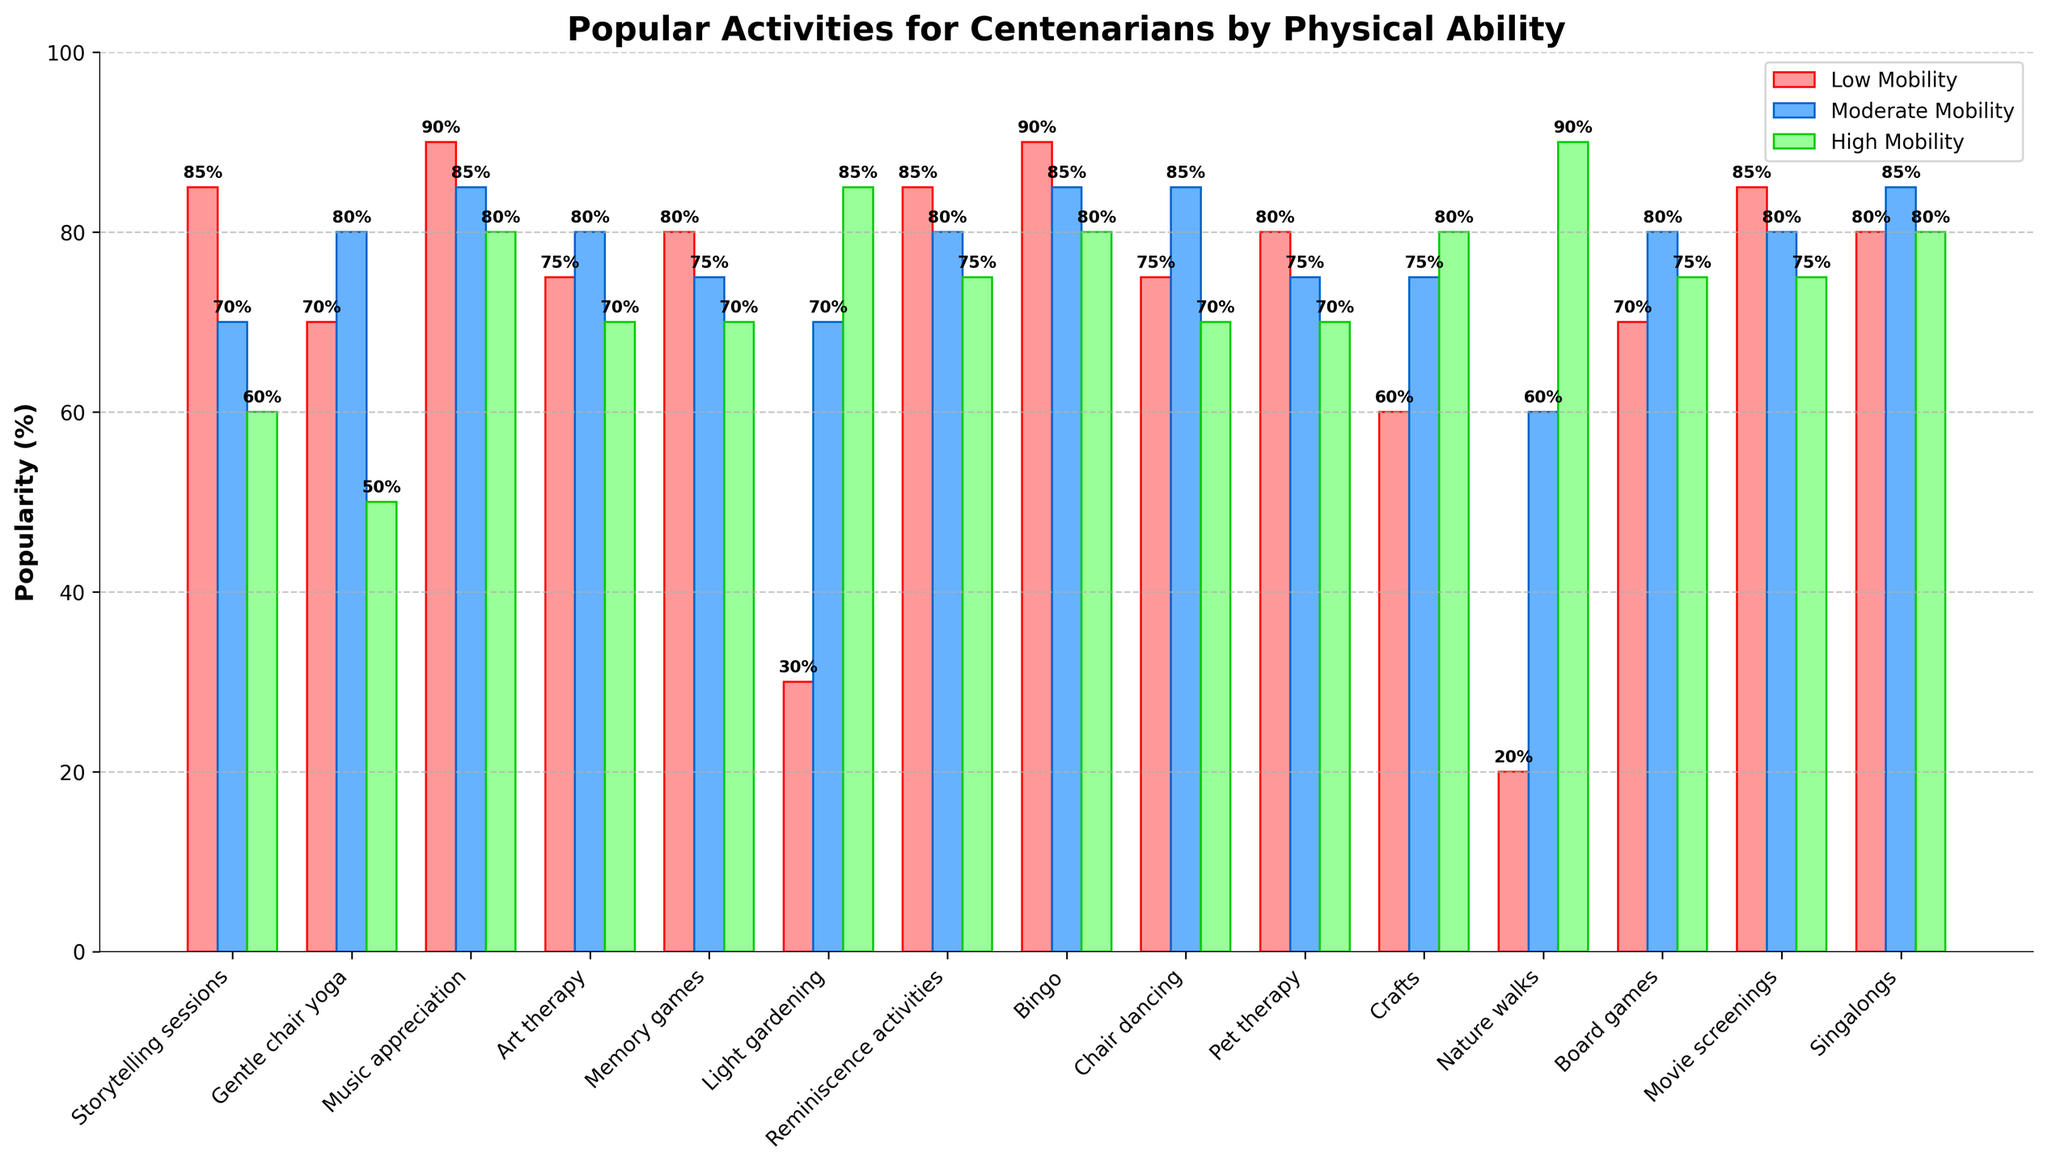What activity is the most popular for centenarians with low mobility? The activity with the highest bar under the 'Low Mobility' category is Music appreciation.
Answer: Music appreciation Which activity shows the greatest difference in popularity between low mobility and high mobility groups? Calculate the difference in popularity for each activity between the low mobility and high mobility groups and identify the activity with the maximum difference. The difference for each activity is as follows: Storytelling sessions (25), Gentle chair yoga (20), Music appreciation (10), Art therapy (5), Memory games (10), Light gardening (55), Reminiscence activities (10), Bingo (10), Chair dancing (5), Pet therapy (10), Crafts (20), Nature walks (70), Board games (5), Movie screenings (10), Singalongs (5). The biggest difference is for Nature walks (20% - 90%) = -70%.
Answer: Nature walks Which activity is equally popular among centenarians with moderate and high mobility? Look for the activity where the heights of the bars for 'Moderate Mobility' and 'High Mobility' are the same. Crafts have equal popularity of 80% among both moderate and high mobility groups.
Answer: Crafts What are the top three activities for high mobility centenarians? Identify the three tallest bars in the 'High Mobility' category. The activities are Nature walks (90%), Light gardening (85%), and Music appreciation (80%).
Answer: Nature walks, Light gardening, Music appreciation For which types of activities do low mobility and moderate mobility centenarians have a difference of 10% or less? Calculate the difference in popularity between the low mobility and moderate mobility groups for each activity. The evaluated differences are: Storytelling sessions (15), Gentle chair yoga (10), Music appreciation (5), Art therapy (5), Memory games (5), Light gardening (40), Reminiscence activities (5), Bingo (5), Chair dancing (10), Pet therapy (5), Crafts (15), Nature walks (40), Board games (10), Movie screenings (5), Singalongs (5). The activities are Music appreciation, Art therapy, Memory games, Reminiscence activities, Bingo, Pet therapy, Movie screenings, and Singalongs.
Answer: Music appreciation, Art therapy, Memory games, Reminiscence activities, Bingo, Pet therapy, Movie screenings, Singalongs Which activity has the smallest popularity difference between all three mobility groups? Calculate the range (highest value - lowest value) for each activity across all three mobility groups. The ranges are: Storytelling sessions (25), Gentle chair yoga (30), Music appreciation (10), Art therapy (10), Memory games (10), Light gardening (55), Reminiscence activities (10), Bingo (10), Chair dancing (15), Pet therapy (10), Crafts (20), Nature walks (70), Board games (10), Movie screenings (10), Singalongs (5). The smallest range is for Singalongs with a range of 5%.
Answer: Singalongs What percentage of centenarians with low mobility enjoy Bingo? Look for the height of the bar representing Bingo under the 'Low Mobility' category. It is 90%.
Answer: 90% Which activity is least popular for high mobility centenarians? Identify the shortest bar under the 'High Mobility' category. Storytelling sessions and Gentle chair yoga both have the smallest percentage of 50%.
Answer: Storytelling sessions, Gentle chair yoga Which activity is the most preferred for centenarians who have moderate mobility? Look at the 'Moderate Mobility' bar and identify the tallest one. The activity is Bingo with 85%.
Answer: Bingo By how much does the popularity of light gardening increase from low mobility to high mobility centenarians? Subtract the percentage of popularity among low mobility from the percentage of popularity among high mobility centenarians for Light gardening (85% - 30% = 55%).
Answer: 55% 